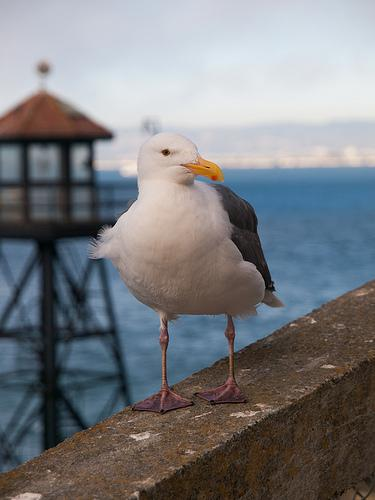Question: where is the seagull standing?
Choices:
A. On the wall.
B. On sand.
C. On a fish's body.
D. On the shore.
Answer with the letter. Answer: A Question: what color is the water?
Choices:
A. Blue.
B. Gray.
C. Green.
D. Turquoise.
Answer with the letter. Answer: A Question: what color is the seagull's beak?
Choices:
A. Orange.
B. Yellow.
C. Brown.
D. Black.
Answer with the letter. Answer: A 